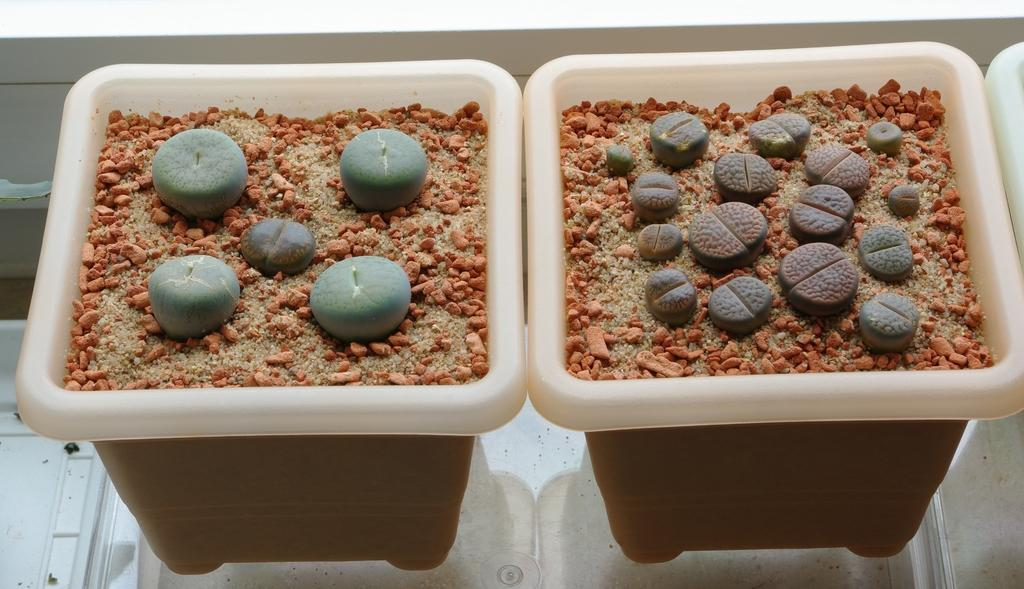What type of surface is visible in the image? There is sand visible in the image. What objects can be seen in the sand? There are pots in the image. What is inside the pots? There are other things in the pots. What direction is the brush facing in the image? There is no brush present in the image. What route is visible in the image? There is no route visible in the image. 